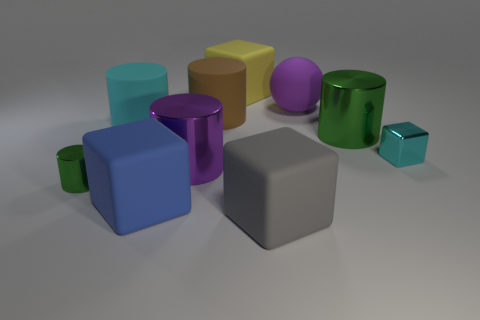Are there more large spheres that are in front of the purple cylinder than large rubber cylinders that are on the left side of the large blue thing?
Your answer should be compact. No. What is the color of the large block that is behind the big metallic thing behind the big purple metal cylinder?
Your answer should be very brief. Yellow. Is the material of the gray object the same as the yellow thing?
Your answer should be compact. Yes. Is there another tiny metallic thing that has the same shape as the small green object?
Offer a very short reply. No. Is the color of the metal cylinder behind the big purple metal cylinder the same as the metallic cube?
Make the answer very short. No. Does the matte block behind the purple ball have the same size as the matte cylinder to the right of the big blue block?
Your answer should be very brief. Yes. What size is the purple cylinder that is the same material as the small cyan block?
Your answer should be compact. Large. What number of cyan objects are both on the right side of the big yellow block and left of the large yellow rubber block?
Your answer should be very brief. 0. How many objects are large red matte things or big things that are in front of the large yellow thing?
Provide a short and direct response. 7. The big thing that is the same color as the small shiny cylinder is what shape?
Offer a terse response. Cylinder. 